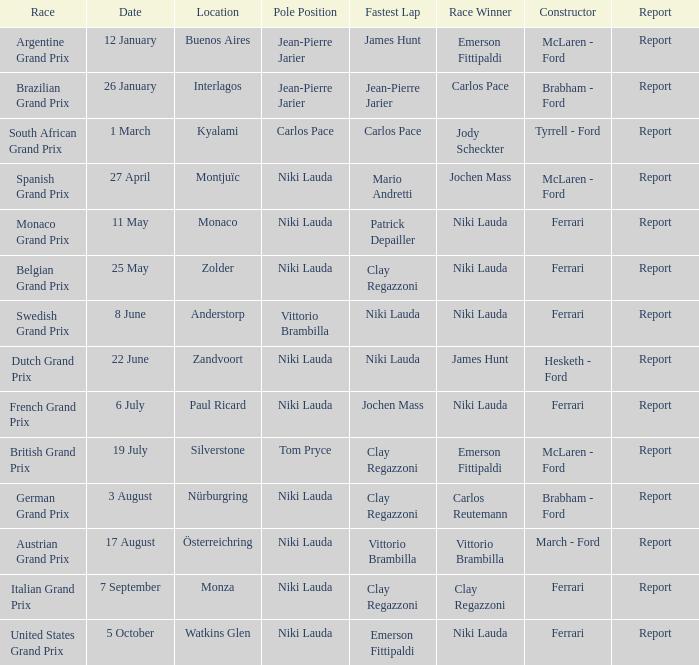Where did the team in which Tom Pryce was in Pole Position race? Silverstone. 